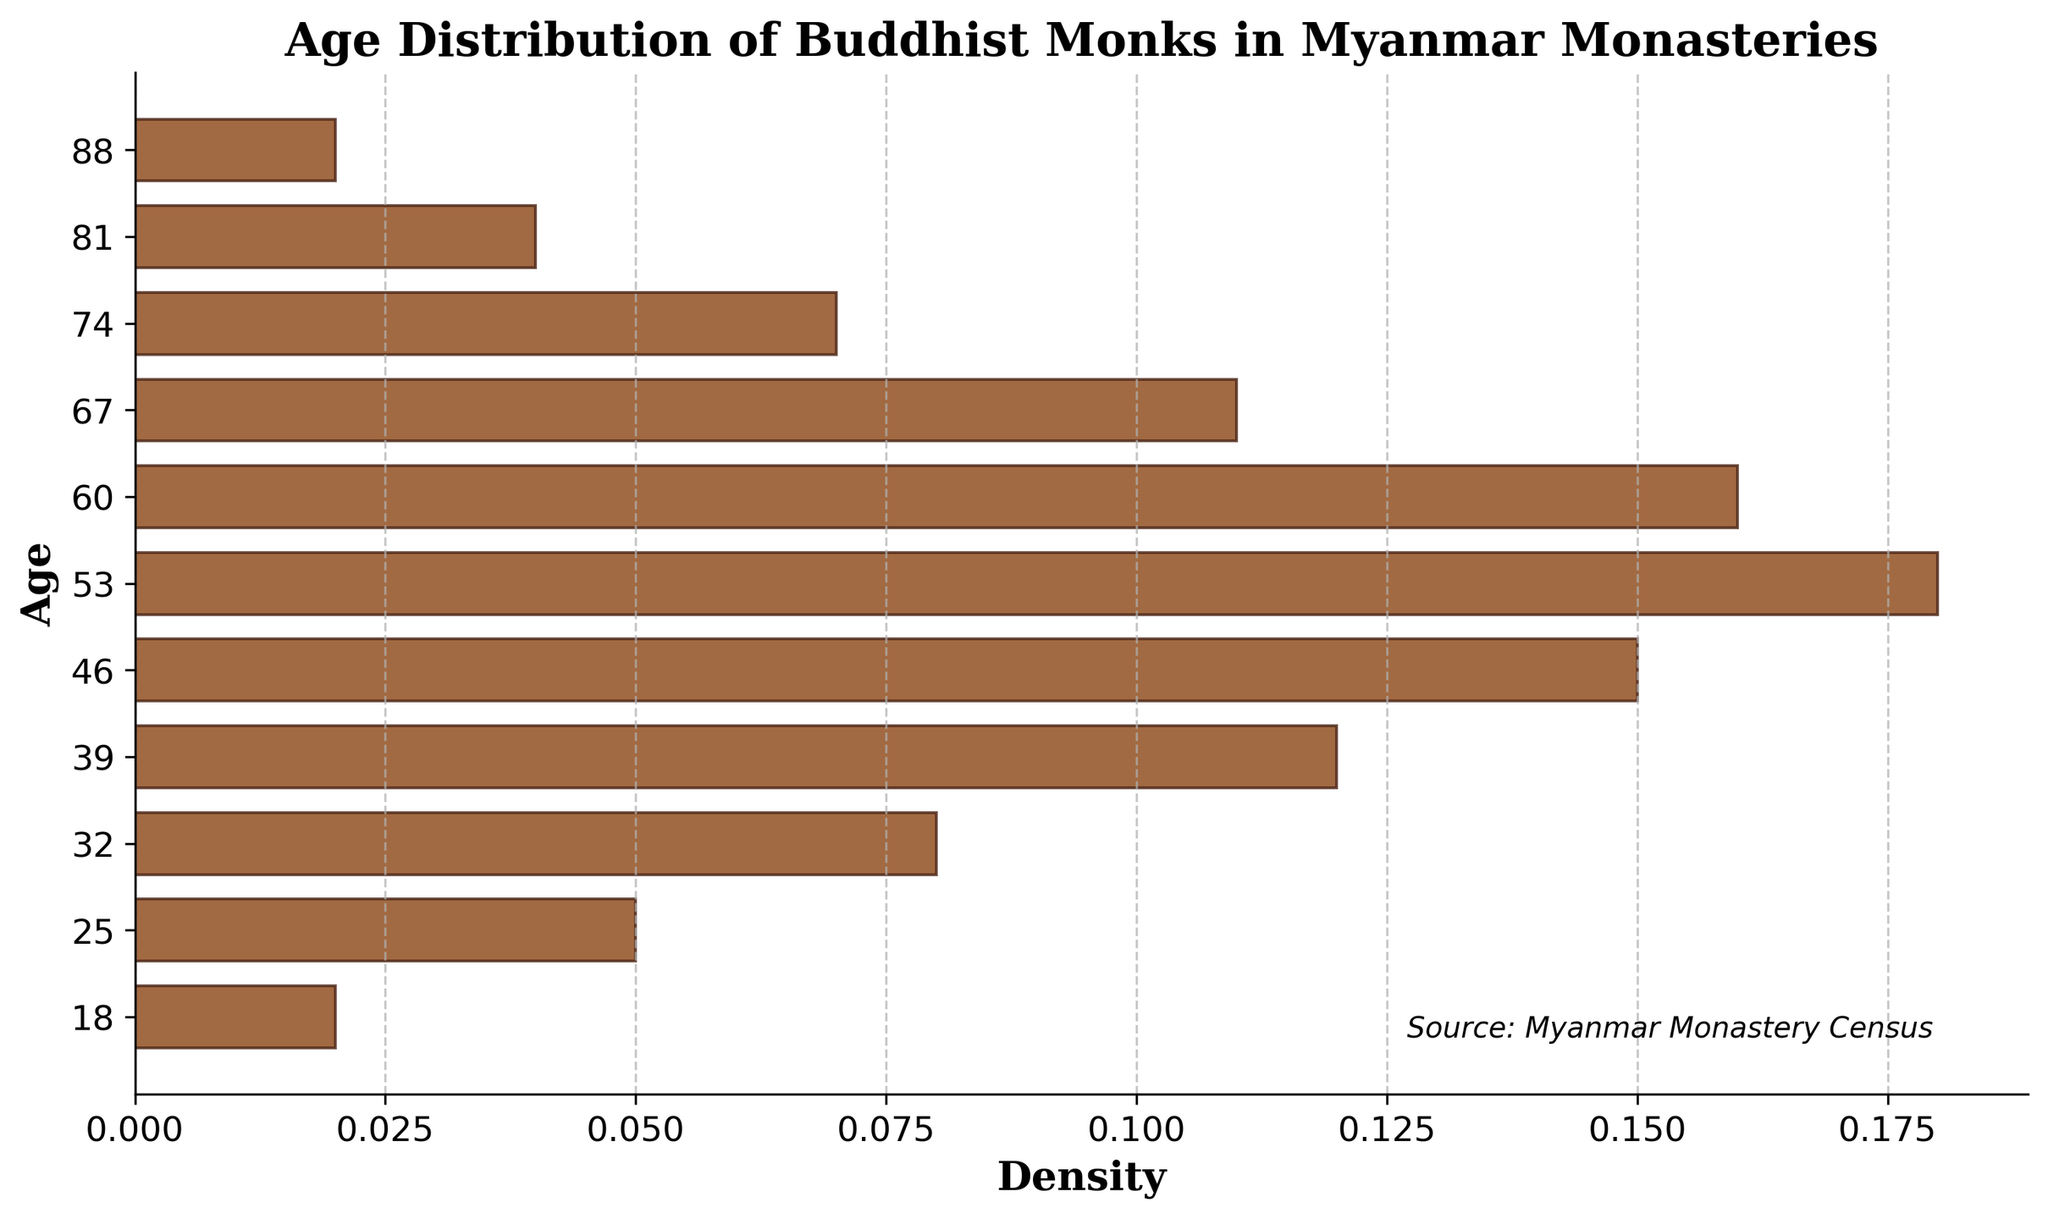How many age groups are represented in the plot? The x-axis of the plot has marks for each age group. Counting these marks tells us the number of age groups.
Answer: 11 What is the title of the plot? The title is usually displayed at the top of the plot. In this case, it's clearly indicated.
Answer: Age Distribution of Buddhist Monks in Myanmar Monasteries Which age group has the highest density? The age group with the highest density can be identified by the longest horizontal bar in the plot.
Answer: 53 What's the density value for the age group 25? Find the horizontal bar that is at the age mark 25 on the y-axis. Its length indicates the density value.
Answer: 0.05 What age groups have the same density value? By comparing the lengths of the horizontal bars, we can identify which ones have the same value. Age groups 18 and 88 have equal lengths, as do 74 and 25.
Answer: 18 and 88; 74 and 25 Which age groups have a density greater than 0.1? Look for bars longer than the mark for 0.1 on the x-axis.
Answer: 39, 46, 53, 60 What is the average density value for all age groups? Sum all density values and divide by the number of age groups. (0.02 + 0.05 + 0.08 + 0.12 + 0.15 + 0.18 + 0.16 + 0.11 + 0.07 + 0.04 + 0.02) / 11 = 1.00 / 11
Answer: 0.091 What is the difference in density between the age groups 53 and 25? Subtract the density of age 25 from the density of age 53. 0.18 - 0.05
Answer: 0.13 What's the range of ages shown in this plot? The range is determined by subtracting the minimum age value from the maximum age value shown on the y-axis. 88 - 18
Answer: 70 Is the density generally increasing or decreasing as age increases from 18 to 53? Observing the plot from age 18 to 53, the bars lengthen, indicating an increasing density.
Answer: Increasing 